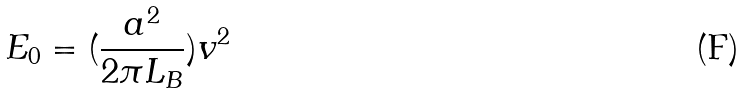Convert formula to latex. <formula><loc_0><loc_0><loc_500><loc_500>E _ { 0 } = ( \frac { a ^ { 2 } } { 2 \pi L _ { B } } ) v ^ { 2 }</formula> 